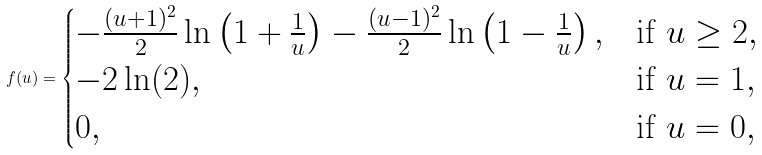<formula> <loc_0><loc_0><loc_500><loc_500>f ( u ) = \begin{cases} - \frac { ( u + 1 ) ^ { 2 } } { 2 } \ln \left ( 1 + \frac { 1 } { u } \right ) - \frac { ( u - 1 ) ^ { 2 } } { 2 } \ln \left ( 1 - \frac { 1 } { u } \right ) , & \text {if $u\geq 2$} , \\ - 2 \ln ( 2 ) , & \text {if $u=1$} , \\ 0 , & \text {if $u=0$} , \end{cases}</formula> 